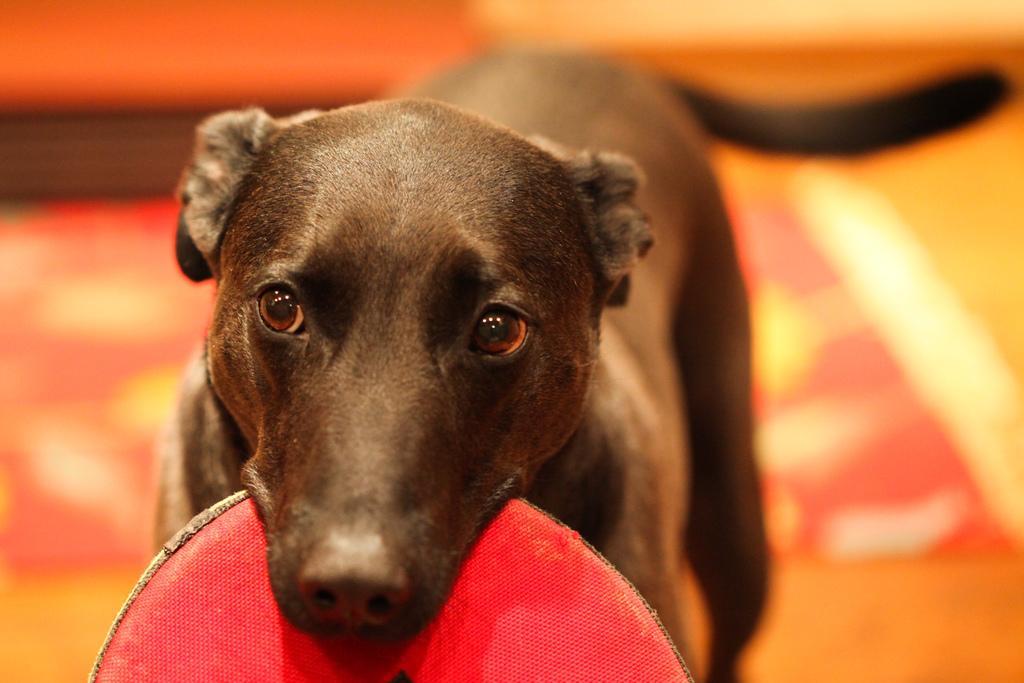Could you give a brief overview of what you see in this image? In this picture we can see a black color dog is holding a disc with its mouth, we can see a blurry background. 